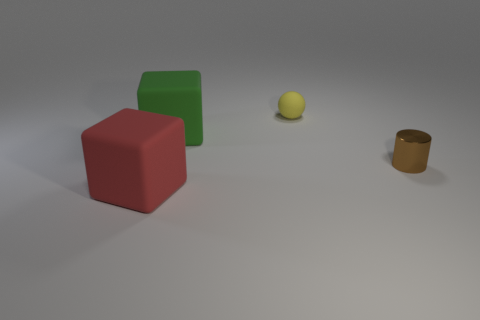How many green objects have the same shape as the small yellow rubber thing?
Offer a very short reply. 0. There is a block in front of the cube behind the thing on the right side of the yellow ball; how big is it?
Give a very brief answer. Large. Is the number of large objects that are behind the big red matte block greater than the number of matte objects?
Make the answer very short. No. Is there a rubber cube?
Your answer should be very brief. Yes. How many brown shiny cylinders are the same size as the green rubber thing?
Ensure brevity in your answer.  0. Are there more tiny metal cylinders behind the tiny yellow thing than green blocks that are in front of the red rubber object?
Provide a short and direct response. No. There is a object that is the same size as the sphere; what is it made of?
Make the answer very short. Metal. The green thing is what shape?
Give a very brief answer. Cube. How many blue objects are matte blocks or metal objects?
Offer a terse response. 0. What is the size of the red cube that is the same material as the yellow ball?
Give a very brief answer. Large. 